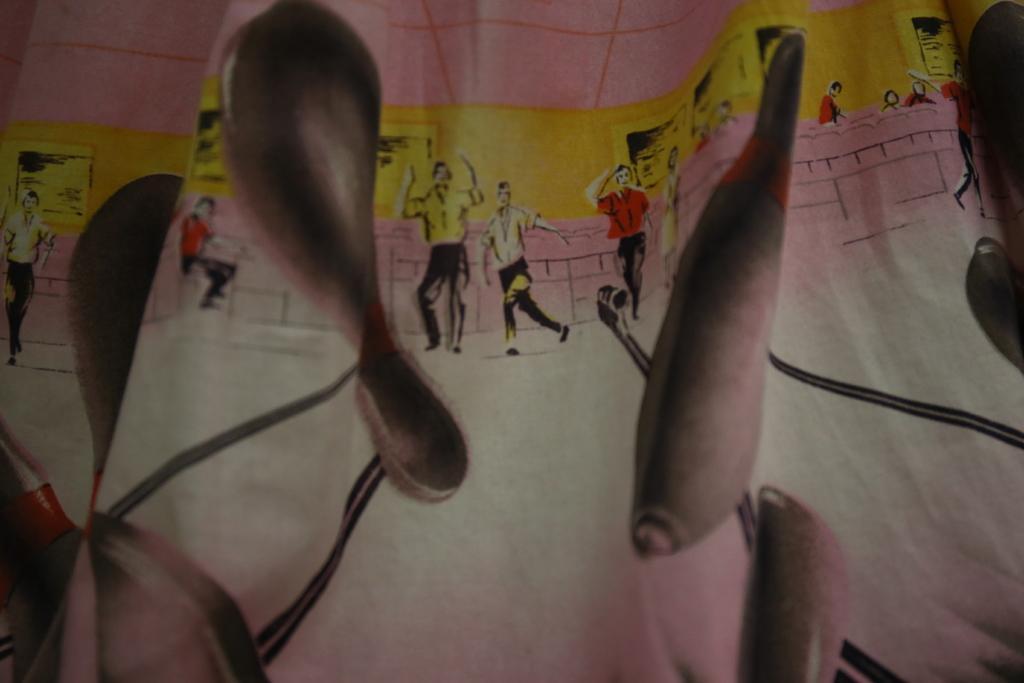How would you summarize this image in a sentence or two? In this image there is a cloth. On the cloth there is a print of pictures on the cloth. There are pictures of toy bowling, persons, chairs and charts on the wall. 